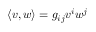<formula> <loc_0><loc_0><loc_500><loc_500>\langle v , w \rangle = g _ { i j } v ^ { i } w ^ { j }</formula> 